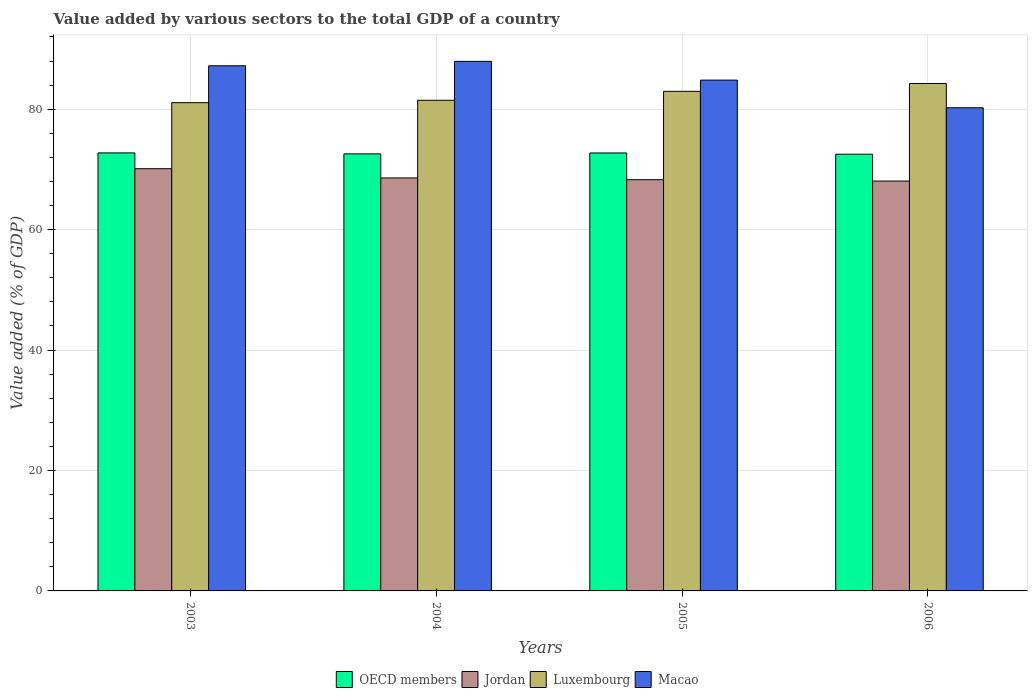How many different coloured bars are there?
Provide a short and direct response. 4. How many groups of bars are there?
Your response must be concise. 4. Are the number of bars on each tick of the X-axis equal?
Provide a short and direct response. Yes. How many bars are there on the 2nd tick from the left?
Offer a terse response. 4. What is the label of the 4th group of bars from the left?
Offer a very short reply. 2006. What is the value added by various sectors to the total GDP in Luxembourg in 2006?
Your response must be concise. 84.28. Across all years, what is the maximum value added by various sectors to the total GDP in Luxembourg?
Offer a very short reply. 84.28. Across all years, what is the minimum value added by various sectors to the total GDP in OECD members?
Provide a succinct answer. 72.53. In which year was the value added by various sectors to the total GDP in OECD members maximum?
Give a very brief answer. 2003. In which year was the value added by various sectors to the total GDP in Luxembourg minimum?
Provide a short and direct response. 2003. What is the total value added by various sectors to the total GDP in Macao in the graph?
Offer a terse response. 340.25. What is the difference between the value added by various sectors to the total GDP in Luxembourg in 2005 and that in 2006?
Provide a short and direct response. -1.3. What is the difference between the value added by various sectors to the total GDP in Macao in 2005 and the value added by various sectors to the total GDP in Luxembourg in 2006?
Give a very brief answer. 0.56. What is the average value added by various sectors to the total GDP in Macao per year?
Your answer should be compact. 85.06. In the year 2004, what is the difference between the value added by various sectors to the total GDP in OECD members and value added by various sectors to the total GDP in Luxembourg?
Keep it short and to the point. -8.9. In how many years, is the value added by various sectors to the total GDP in OECD members greater than 36 %?
Ensure brevity in your answer.  4. What is the ratio of the value added by various sectors to the total GDP in OECD members in 2003 to that in 2006?
Ensure brevity in your answer.  1. Is the difference between the value added by various sectors to the total GDP in OECD members in 2004 and 2005 greater than the difference between the value added by various sectors to the total GDP in Luxembourg in 2004 and 2005?
Keep it short and to the point. Yes. What is the difference between the highest and the second highest value added by various sectors to the total GDP in OECD members?
Your response must be concise. 0.01. What is the difference between the highest and the lowest value added by various sectors to the total GDP in OECD members?
Make the answer very short. 0.22. Is the sum of the value added by various sectors to the total GDP in OECD members in 2005 and 2006 greater than the maximum value added by various sectors to the total GDP in Jordan across all years?
Make the answer very short. Yes. Is it the case that in every year, the sum of the value added by various sectors to the total GDP in Luxembourg and value added by various sectors to the total GDP in Jordan is greater than the sum of value added by various sectors to the total GDP in OECD members and value added by various sectors to the total GDP in Macao?
Your answer should be compact. No. What does the 1st bar from the left in 2004 represents?
Your answer should be very brief. OECD members. What does the 4th bar from the right in 2004 represents?
Your answer should be very brief. OECD members. Is it the case that in every year, the sum of the value added by various sectors to the total GDP in Luxembourg and value added by various sectors to the total GDP in OECD members is greater than the value added by various sectors to the total GDP in Jordan?
Give a very brief answer. Yes. How many bars are there?
Provide a succinct answer. 16. Are all the bars in the graph horizontal?
Your answer should be compact. No. Are the values on the major ticks of Y-axis written in scientific E-notation?
Offer a terse response. No. Does the graph contain any zero values?
Provide a succinct answer. No. Where does the legend appear in the graph?
Ensure brevity in your answer.  Bottom center. How many legend labels are there?
Your answer should be compact. 4. How are the legend labels stacked?
Offer a very short reply. Horizontal. What is the title of the graph?
Provide a short and direct response. Value added by various sectors to the total GDP of a country. What is the label or title of the Y-axis?
Ensure brevity in your answer.  Value added (% of GDP). What is the Value added (% of GDP) of OECD members in 2003?
Make the answer very short. 72.75. What is the Value added (% of GDP) in Jordan in 2003?
Your response must be concise. 70.12. What is the Value added (% of GDP) in Luxembourg in 2003?
Ensure brevity in your answer.  81.09. What is the Value added (% of GDP) in Macao in 2003?
Ensure brevity in your answer.  87.22. What is the Value added (% of GDP) of OECD members in 2004?
Your answer should be very brief. 72.59. What is the Value added (% of GDP) of Jordan in 2004?
Your response must be concise. 68.59. What is the Value added (% of GDP) in Luxembourg in 2004?
Your answer should be very brief. 81.49. What is the Value added (% of GDP) of Macao in 2004?
Your answer should be compact. 87.95. What is the Value added (% of GDP) in OECD members in 2005?
Provide a succinct answer. 72.74. What is the Value added (% of GDP) in Jordan in 2005?
Provide a short and direct response. 68.3. What is the Value added (% of GDP) of Luxembourg in 2005?
Give a very brief answer. 82.97. What is the Value added (% of GDP) in Macao in 2005?
Give a very brief answer. 84.83. What is the Value added (% of GDP) of OECD members in 2006?
Your response must be concise. 72.53. What is the Value added (% of GDP) of Jordan in 2006?
Provide a short and direct response. 68.07. What is the Value added (% of GDP) of Luxembourg in 2006?
Provide a short and direct response. 84.28. What is the Value added (% of GDP) of Macao in 2006?
Ensure brevity in your answer.  80.25. Across all years, what is the maximum Value added (% of GDP) of OECD members?
Provide a succinct answer. 72.75. Across all years, what is the maximum Value added (% of GDP) of Jordan?
Give a very brief answer. 70.12. Across all years, what is the maximum Value added (% of GDP) in Luxembourg?
Your response must be concise. 84.28. Across all years, what is the maximum Value added (% of GDP) of Macao?
Provide a short and direct response. 87.95. Across all years, what is the minimum Value added (% of GDP) in OECD members?
Offer a very short reply. 72.53. Across all years, what is the minimum Value added (% of GDP) in Jordan?
Make the answer very short. 68.07. Across all years, what is the minimum Value added (% of GDP) in Luxembourg?
Offer a terse response. 81.09. Across all years, what is the minimum Value added (% of GDP) in Macao?
Provide a succinct answer. 80.25. What is the total Value added (% of GDP) in OECD members in the graph?
Your answer should be very brief. 290.61. What is the total Value added (% of GDP) in Jordan in the graph?
Provide a succinct answer. 275.08. What is the total Value added (% of GDP) in Luxembourg in the graph?
Keep it short and to the point. 329.83. What is the total Value added (% of GDP) of Macao in the graph?
Give a very brief answer. 340.25. What is the difference between the Value added (% of GDP) of OECD members in 2003 and that in 2004?
Offer a terse response. 0.16. What is the difference between the Value added (% of GDP) of Jordan in 2003 and that in 2004?
Your answer should be compact. 1.53. What is the difference between the Value added (% of GDP) in Luxembourg in 2003 and that in 2004?
Offer a very short reply. -0.4. What is the difference between the Value added (% of GDP) in Macao in 2003 and that in 2004?
Offer a very short reply. -0.73. What is the difference between the Value added (% of GDP) in OECD members in 2003 and that in 2005?
Give a very brief answer. 0.01. What is the difference between the Value added (% of GDP) of Jordan in 2003 and that in 2005?
Provide a short and direct response. 1.83. What is the difference between the Value added (% of GDP) of Luxembourg in 2003 and that in 2005?
Ensure brevity in your answer.  -1.88. What is the difference between the Value added (% of GDP) of Macao in 2003 and that in 2005?
Your answer should be very brief. 2.38. What is the difference between the Value added (% of GDP) of OECD members in 2003 and that in 2006?
Your response must be concise. 0.22. What is the difference between the Value added (% of GDP) in Jordan in 2003 and that in 2006?
Provide a succinct answer. 2.05. What is the difference between the Value added (% of GDP) of Luxembourg in 2003 and that in 2006?
Your response must be concise. -3.19. What is the difference between the Value added (% of GDP) in Macao in 2003 and that in 2006?
Your answer should be compact. 6.97. What is the difference between the Value added (% of GDP) in OECD members in 2004 and that in 2005?
Your response must be concise. -0.15. What is the difference between the Value added (% of GDP) in Jordan in 2004 and that in 2005?
Provide a short and direct response. 0.29. What is the difference between the Value added (% of GDP) of Luxembourg in 2004 and that in 2005?
Provide a succinct answer. -1.48. What is the difference between the Value added (% of GDP) of Macao in 2004 and that in 2005?
Keep it short and to the point. 3.12. What is the difference between the Value added (% of GDP) of OECD members in 2004 and that in 2006?
Offer a terse response. 0.06. What is the difference between the Value added (% of GDP) of Jordan in 2004 and that in 2006?
Offer a terse response. 0.52. What is the difference between the Value added (% of GDP) in Luxembourg in 2004 and that in 2006?
Your answer should be very brief. -2.79. What is the difference between the Value added (% of GDP) of Macao in 2004 and that in 2006?
Offer a terse response. 7.71. What is the difference between the Value added (% of GDP) in OECD members in 2005 and that in 2006?
Your answer should be very brief. 0.21. What is the difference between the Value added (% of GDP) of Jordan in 2005 and that in 2006?
Keep it short and to the point. 0.22. What is the difference between the Value added (% of GDP) in Luxembourg in 2005 and that in 2006?
Offer a terse response. -1.3. What is the difference between the Value added (% of GDP) of Macao in 2005 and that in 2006?
Your answer should be compact. 4.59. What is the difference between the Value added (% of GDP) in OECD members in 2003 and the Value added (% of GDP) in Jordan in 2004?
Give a very brief answer. 4.16. What is the difference between the Value added (% of GDP) in OECD members in 2003 and the Value added (% of GDP) in Luxembourg in 2004?
Provide a succinct answer. -8.74. What is the difference between the Value added (% of GDP) in OECD members in 2003 and the Value added (% of GDP) in Macao in 2004?
Make the answer very short. -15.2. What is the difference between the Value added (% of GDP) in Jordan in 2003 and the Value added (% of GDP) in Luxembourg in 2004?
Provide a short and direct response. -11.37. What is the difference between the Value added (% of GDP) of Jordan in 2003 and the Value added (% of GDP) of Macao in 2004?
Offer a very short reply. -17.83. What is the difference between the Value added (% of GDP) in Luxembourg in 2003 and the Value added (% of GDP) in Macao in 2004?
Your response must be concise. -6.86. What is the difference between the Value added (% of GDP) in OECD members in 2003 and the Value added (% of GDP) in Jordan in 2005?
Offer a terse response. 4.45. What is the difference between the Value added (% of GDP) of OECD members in 2003 and the Value added (% of GDP) of Luxembourg in 2005?
Offer a very short reply. -10.22. What is the difference between the Value added (% of GDP) in OECD members in 2003 and the Value added (% of GDP) in Macao in 2005?
Your answer should be very brief. -12.09. What is the difference between the Value added (% of GDP) in Jordan in 2003 and the Value added (% of GDP) in Luxembourg in 2005?
Your response must be concise. -12.85. What is the difference between the Value added (% of GDP) in Jordan in 2003 and the Value added (% of GDP) in Macao in 2005?
Provide a succinct answer. -14.71. What is the difference between the Value added (% of GDP) in Luxembourg in 2003 and the Value added (% of GDP) in Macao in 2005?
Provide a short and direct response. -3.75. What is the difference between the Value added (% of GDP) in OECD members in 2003 and the Value added (% of GDP) in Jordan in 2006?
Ensure brevity in your answer.  4.68. What is the difference between the Value added (% of GDP) of OECD members in 2003 and the Value added (% of GDP) of Luxembourg in 2006?
Your answer should be compact. -11.53. What is the difference between the Value added (% of GDP) in OECD members in 2003 and the Value added (% of GDP) in Macao in 2006?
Give a very brief answer. -7.5. What is the difference between the Value added (% of GDP) of Jordan in 2003 and the Value added (% of GDP) of Luxembourg in 2006?
Provide a succinct answer. -14.15. What is the difference between the Value added (% of GDP) in Jordan in 2003 and the Value added (% of GDP) in Macao in 2006?
Offer a terse response. -10.12. What is the difference between the Value added (% of GDP) in Luxembourg in 2003 and the Value added (% of GDP) in Macao in 2006?
Provide a short and direct response. 0.84. What is the difference between the Value added (% of GDP) in OECD members in 2004 and the Value added (% of GDP) in Jordan in 2005?
Give a very brief answer. 4.29. What is the difference between the Value added (% of GDP) of OECD members in 2004 and the Value added (% of GDP) of Luxembourg in 2005?
Make the answer very short. -10.38. What is the difference between the Value added (% of GDP) in OECD members in 2004 and the Value added (% of GDP) in Macao in 2005?
Your response must be concise. -12.25. What is the difference between the Value added (% of GDP) in Jordan in 2004 and the Value added (% of GDP) in Luxembourg in 2005?
Ensure brevity in your answer.  -14.38. What is the difference between the Value added (% of GDP) of Jordan in 2004 and the Value added (% of GDP) of Macao in 2005?
Provide a short and direct response. -16.24. What is the difference between the Value added (% of GDP) of Luxembourg in 2004 and the Value added (% of GDP) of Macao in 2005?
Provide a short and direct response. -3.35. What is the difference between the Value added (% of GDP) in OECD members in 2004 and the Value added (% of GDP) in Jordan in 2006?
Your response must be concise. 4.52. What is the difference between the Value added (% of GDP) in OECD members in 2004 and the Value added (% of GDP) in Luxembourg in 2006?
Give a very brief answer. -11.69. What is the difference between the Value added (% of GDP) of OECD members in 2004 and the Value added (% of GDP) of Macao in 2006?
Your answer should be compact. -7.66. What is the difference between the Value added (% of GDP) of Jordan in 2004 and the Value added (% of GDP) of Luxembourg in 2006?
Ensure brevity in your answer.  -15.69. What is the difference between the Value added (% of GDP) in Jordan in 2004 and the Value added (% of GDP) in Macao in 2006?
Provide a succinct answer. -11.66. What is the difference between the Value added (% of GDP) of Luxembourg in 2004 and the Value added (% of GDP) of Macao in 2006?
Your answer should be compact. 1.24. What is the difference between the Value added (% of GDP) of OECD members in 2005 and the Value added (% of GDP) of Jordan in 2006?
Provide a short and direct response. 4.66. What is the difference between the Value added (% of GDP) of OECD members in 2005 and the Value added (% of GDP) of Luxembourg in 2006?
Make the answer very short. -11.54. What is the difference between the Value added (% of GDP) of OECD members in 2005 and the Value added (% of GDP) of Macao in 2006?
Make the answer very short. -7.51. What is the difference between the Value added (% of GDP) of Jordan in 2005 and the Value added (% of GDP) of Luxembourg in 2006?
Offer a very short reply. -15.98. What is the difference between the Value added (% of GDP) of Jordan in 2005 and the Value added (% of GDP) of Macao in 2006?
Ensure brevity in your answer.  -11.95. What is the difference between the Value added (% of GDP) of Luxembourg in 2005 and the Value added (% of GDP) of Macao in 2006?
Your response must be concise. 2.72. What is the average Value added (% of GDP) of OECD members per year?
Offer a very short reply. 72.65. What is the average Value added (% of GDP) in Jordan per year?
Ensure brevity in your answer.  68.77. What is the average Value added (% of GDP) in Luxembourg per year?
Make the answer very short. 82.46. What is the average Value added (% of GDP) in Macao per year?
Provide a succinct answer. 85.06. In the year 2003, what is the difference between the Value added (% of GDP) of OECD members and Value added (% of GDP) of Jordan?
Provide a succinct answer. 2.62. In the year 2003, what is the difference between the Value added (% of GDP) in OECD members and Value added (% of GDP) in Luxembourg?
Your answer should be very brief. -8.34. In the year 2003, what is the difference between the Value added (% of GDP) of OECD members and Value added (% of GDP) of Macao?
Your answer should be very brief. -14.47. In the year 2003, what is the difference between the Value added (% of GDP) in Jordan and Value added (% of GDP) in Luxembourg?
Give a very brief answer. -10.96. In the year 2003, what is the difference between the Value added (% of GDP) of Jordan and Value added (% of GDP) of Macao?
Your response must be concise. -17.09. In the year 2003, what is the difference between the Value added (% of GDP) in Luxembourg and Value added (% of GDP) in Macao?
Your response must be concise. -6.13. In the year 2004, what is the difference between the Value added (% of GDP) of OECD members and Value added (% of GDP) of Jordan?
Offer a very short reply. 4. In the year 2004, what is the difference between the Value added (% of GDP) of OECD members and Value added (% of GDP) of Luxembourg?
Ensure brevity in your answer.  -8.9. In the year 2004, what is the difference between the Value added (% of GDP) in OECD members and Value added (% of GDP) in Macao?
Provide a succinct answer. -15.36. In the year 2004, what is the difference between the Value added (% of GDP) in Jordan and Value added (% of GDP) in Luxembourg?
Your response must be concise. -12.9. In the year 2004, what is the difference between the Value added (% of GDP) of Jordan and Value added (% of GDP) of Macao?
Provide a succinct answer. -19.36. In the year 2004, what is the difference between the Value added (% of GDP) in Luxembourg and Value added (% of GDP) in Macao?
Ensure brevity in your answer.  -6.46. In the year 2005, what is the difference between the Value added (% of GDP) of OECD members and Value added (% of GDP) of Jordan?
Ensure brevity in your answer.  4.44. In the year 2005, what is the difference between the Value added (% of GDP) in OECD members and Value added (% of GDP) in Luxembourg?
Ensure brevity in your answer.  -10.24. In the year 2005, what is the difference between the Value added (% of GDP) of OECD members and Value added (% of GDP) of Macao?
Make the answer very short. -12.1. In the year 2005, what is the difference between the Value added (% of GDP) in Jordan and Value added (% of GDP) in Luxembourg?
Your response must be concise. -14.68. In the year 2005, what is the difference between the Value added (% of GDP) in Jordan and Value added (% of GDP) in Macao?
Give a very brief answer. -16.54. In the year 2005, what is the difference between the Value added (% of GDP) in Luxembourg and Value added (% of GDP) in Macao?
Your answer should be compact. -1.86. In the year 2006, what is the difference between the Value added (% of GDP) of OECD members and Value added (% of GDP) of Jordan?
Give a very brief answer. 4.46. In the year 2006, what is the difference between the Value added (% of GDP) of OECD members and Value added (% of GDP) of Luxembourg?
Keep it short and to the point. -11.74. In the year 2006, what is the difference between the Value added (% of GDP) in OECD members and Value added (% of GDP) in Macao?
Keep it short and to the point. -7.72. In the year 2006, what is the difference between the Value added (% of GDP) in Jordan and Value added (% of GDP) in Luxembourg?
Give a very brief answer. -16.2. In the year 2006, what is the difference between the Value added (% of GDP) of Jordan and Value added (% of GDP) of Macao?
Give a very brief answer. -12.17. In the year 2006, what is the difference between the Value added (% of GDP) of Luxembourg and Value added (% of GDP) of Macao?
Provide a short and direct response. 4.03. What is the ratio of the Value added (% of GDP) of OECD members in 2003 to that in 2004?
Your answer should be compact. 1. What is the ratio of the Value added (% of GDP) of Jordan in 2003 to that in 2004?
Provide a short and direct response. 1.02. What is the ratio of the Value added (% of GDP) of OECD members in 2003 to that in 2005?
Your answer should be very brief. 1. What is the ratio of the Value added (% of GDP) in Jordan in 2003 to that in 2005?
Keep it short and to the point. 1.03. What is the ratio of the Value added (% of GDP) of Luxembourg in 2003 to that in 2005?
Keep it short and to the point. 0.98. What is the ratio of the Value added (% of GDP) of Macao in 2003 to that in 2005?
Keep it short and to the point. 1.03. What is the ratio of the Value added (% of GDP) of Jordan in 2003 to that in 2006?
Your response must be concise. 1.03. What is the ratio of the Value added (% of GDP) of Luxembourg in 2003 to that in 2006?
Your answer should be very brief. 0.96. What is the ratio of the Value added (% of GDP) in Macao in 2003 to that in 2006?
Make the answer very short. 1.09. What is the ratio of the Value added (% of GDP) of OECD members in 2004 to that in 2005?
Your response must be concise. 1. What is the ratio of the Value added (% of GDP) in Luxembourg in 2004 to that in 2005?
Give a very brief answer. 0.98. What is the ratio of the Value added (% of GDP) of Macao in 2004 to that in 2005?
Provide a succinct answer. 1.04. What is the ratio of the Value added (% of GDP) of Jordan in 2004 to that in 2006?
Ensure brevity in your answer.  1.01. What is the ratio of the Value added (% of GDP) of Luxembourg in 2004 to that in 2006?
Your response must be concise. 0.97. What is the ratio of the Value added (% of GDP) of Macao in 2004 to that in 2006?
Ensure brevity in your answer.  1.1. What is the ratio of the Value added (% of GDP) of OECD members in 2005 to that in 2006?
Give a very brief answer. 1. What is the ratio of the Value added (% of GDP) of Luxembourg in 2005 to that in 2006?
Keep it short and to the point. 0.98. What is the ratio of the Value added (% of GDP) in Macao in 2005 to that in 2006?
Make the answer very short. 1.06. What is the difference between the highest and the second highest Value added (% of GDP) in OECD members?
Offer a very short reply. 0.01. What is the difference between the highest and the second highest Value added (% of GDP) in Jordan?
Ensure brevity in your answer.  1.53. What is the difference between the highest and the second highest Value added (% of GDP) in Luxembourg?
Make the answer very short. 1.3. What is the difference between the highest and the second highest Value added (% of GDP) of Macao?
Offer a terse response. 0.73. What is the difference between the highest and the lowest Value added (% of GDP) of OECD members?
Offer a terse response. 0.22. What is the difference between the highest and the lowest Value added (% of GDP) of Jordan?
Provide a short and direct response. 2.05. What is the difference between the highest and the lowest Value added (% of GDP) of Luxembourg?
Keep it short and to the point. 3.19. What is the difference between the highest and the lowest Value added (% of GDP) of Macao?
Make the answer very short. 7.71. 